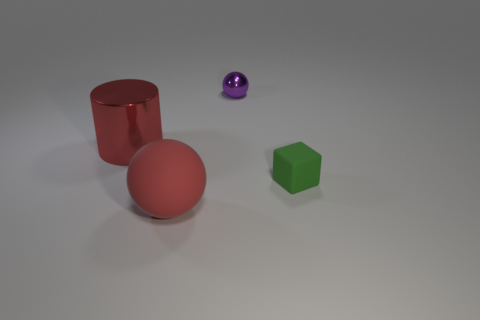What time of day or lighting setting does the scene suggest? The lighting in the scene does not suggest a specific time of day as it appears to be in an artificial environment with neutral and diffused lighting that casts subtle shadows, indicating an indoor setting possibly under studio lighting conditions. 